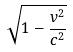<formula> <loc_0><loc_0><loc_500><loc_500>\sqrt { 1 - \frac { v ^ { 2 } } { c ^ { 2 } } }</formula> 